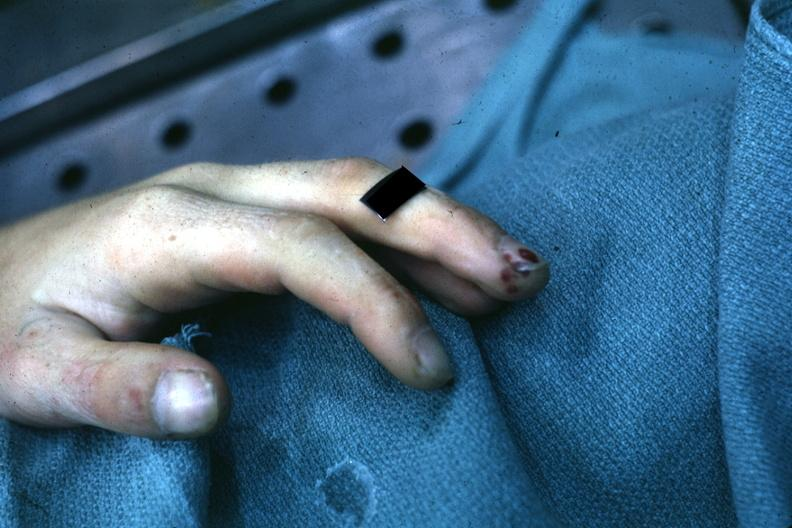re liver with tuberculoid granuloma in glissons present?
Answer the question using a single word or phrase. No 